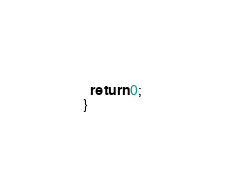Convert code to text. <code><loc_0><loc_0><loc_500><loc_500><_C++_>  return 0;
}
</code> 